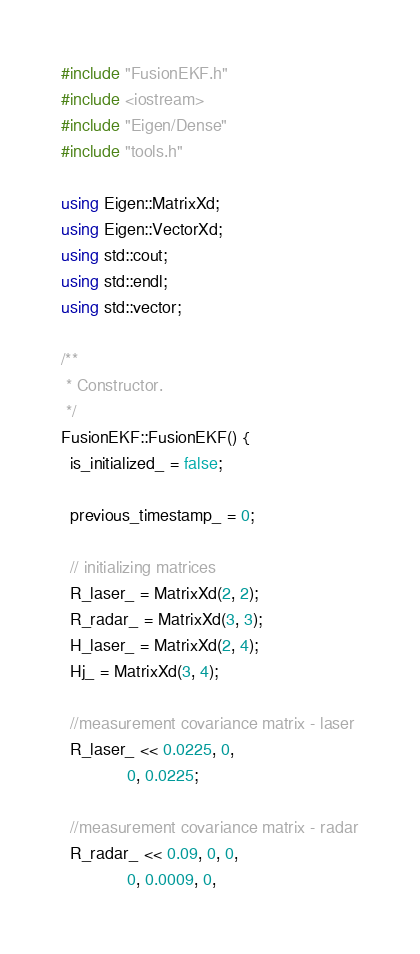Convert code to text. <code><loc_0><loc_0><loc_500><loc_500><_C++_>#include "FusionEKF.h"
#include <iostream>
#include "Eigen/Dense"
#include "tools.h"

using Eigen::MatrixXd;
using Eigen::VectorXd;
using std::cout;
using std::endl;
using std::vector;

/**
 * Constructor.
 */
FusionEKF::FusionEKF() {
  is_initialized_ = false;

  previous_timestamp_ = 0;

  // initializing matrices
  R_laser_ = MatrixXd(2, 2);
  R_radar_ = MatrixXd(3, 3);
  H_laser_ = MatrixXd(2, 4);
  Hj_ = MatrixXd(3, 4);

  //measurement covariance matrix - laser
  R_laser_ << 0.0225, 0,
              0, 0.0225;

  //measurement covariance matrix - radar
  R_radar_ << 0.09, 0, 0,
              0, 0.0009, 0,</code> 